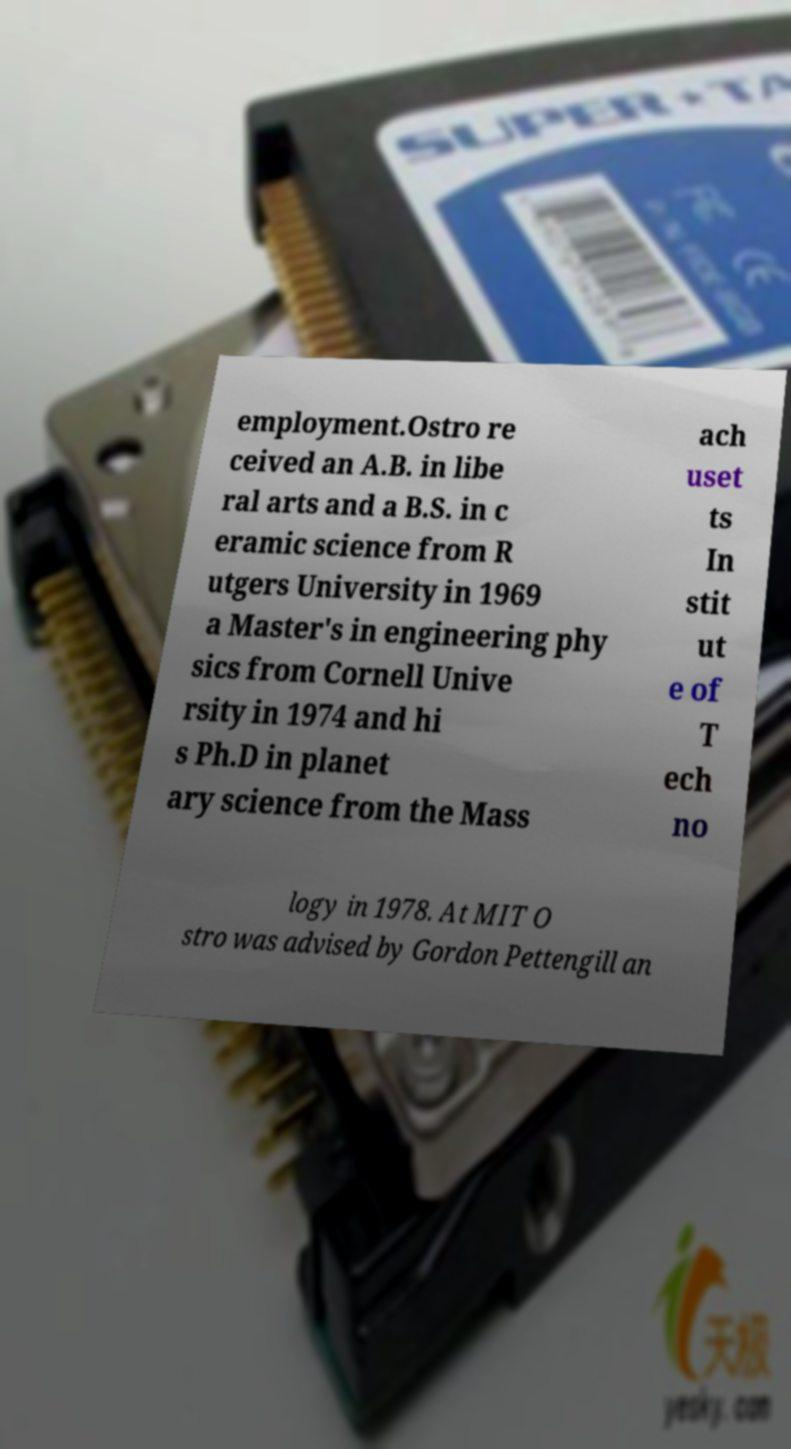What messages or text are displayed in this image? I need them in a readable, typed format. employment.Ostro re ceived an A.B. in libe ral arts and a B.S. in c eramic science from R utgers University in 1969 a Master's in engineering phy sics from Cornell Unive rsity in 1974 and hi s Ph.D in planet ary science from the Mass ach uset ts In stit ut e of T ech no logy in 1978. At MIT O stro was advised by Gordon Pettengill an 